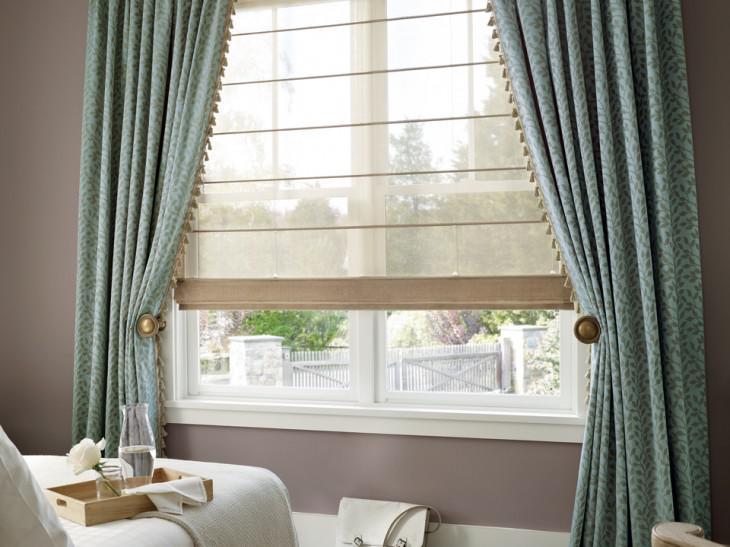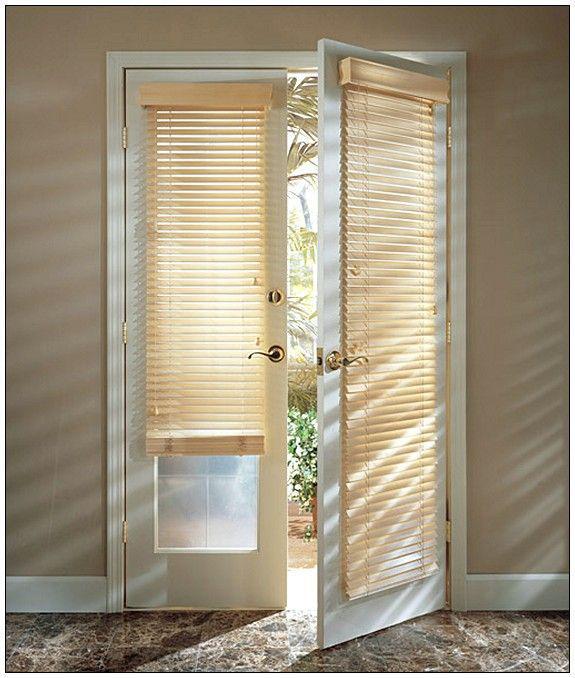The first image is the image on the left, the second image is the image on the right. Given the left and right images, does the statement "There are three blinds." hold true? Answer yes or no. Yes. The first image is the image on the left, the second image is the image on the right. Examine the images to the left and right. Is the description "There are exactly three shades." accurate? Answer yes or no. Yes. 